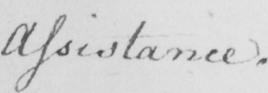Can you read and transcribe this handwriting? Assistance . 